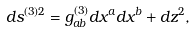<formula> <loc_0><loc_0><loc_500><loc_500>d s ^ { ( 3 ) 2 } = g _ { a b } ^ { ( 3 ) } d x ^ { a } d x ^ { b } + d z ^ { 2 } ,</formula> 